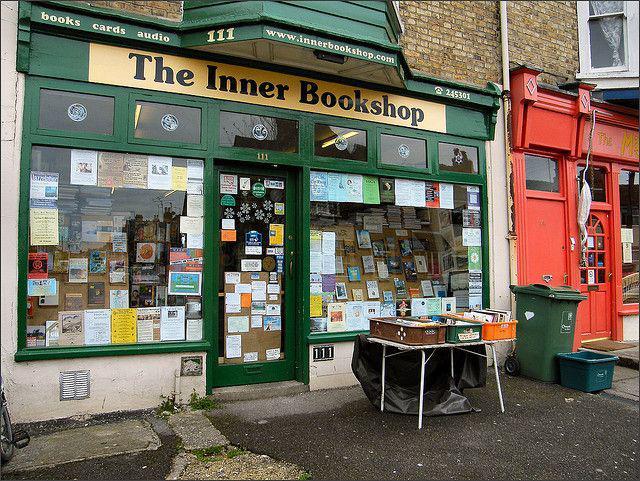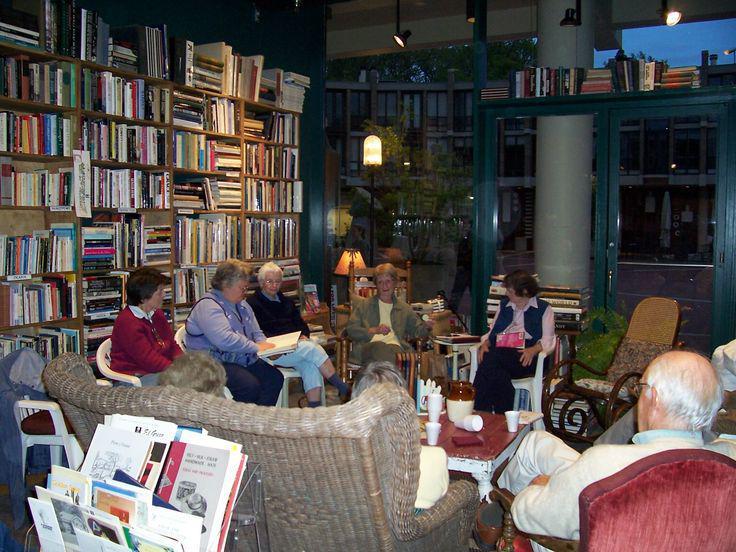The first image is the image on the left, the second image is the image on the right. Assess this claim about the two images: "The people in the shop are standing up and browsing.". Correct or not? Answer yes or no. No. The first image is the image on the left, the second image is the image on the right. Evaluate the accuracy of this statement regarding the images: "The left image shows the exterior of a shop with dark green signage and at least one table of items in front of one of the square glass windows flanking a single door.". Is it true? Answer yes or no. Yes. 